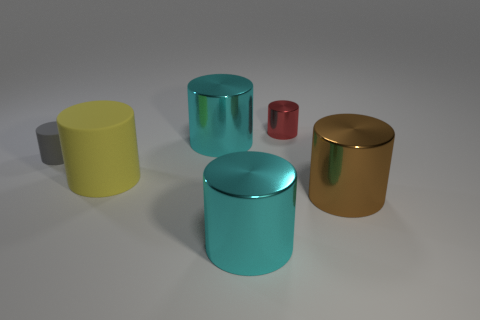What number of cyan metal objects are in front of the large brown metal cylinder and behind the brown cylinder?
Give a very brief answer. 0. There is a object that is the same material as the gray cylinder; what is its size?
Provide a succinct answer. Large. What number of gray things are the same shape as the large yellow rubber object?
Keep it short and to the point. 1. Is the number of large things behind the brown cylinder greater than the number of cylinders?
Keep it short and to the point. No. The large object that is both in front of the large yellow rubber thing and on the left side of the red cylinder has what shape?
Your answer should be very brief. Cylinder. Do the gray object and the brown object have the same size?
Keep it short and to the point. No. There is a big yellow object; how many large cylinders are behind it?
Ensure brevity in your answer.  1. Is the number of big cyan cylinders in front of the tiny red cylinder the same as the number of cyan metallic things that are on the right side of the tiny gray object?
Your answer should be very brief. Yes. Are there any other things that are made of the same material as the tiny red thing?
Give a very brief answer. Yes. Is the size of the yellow rubber object the same as the gray object left of the brown cylinder?
Provide a short and direct response. No. 